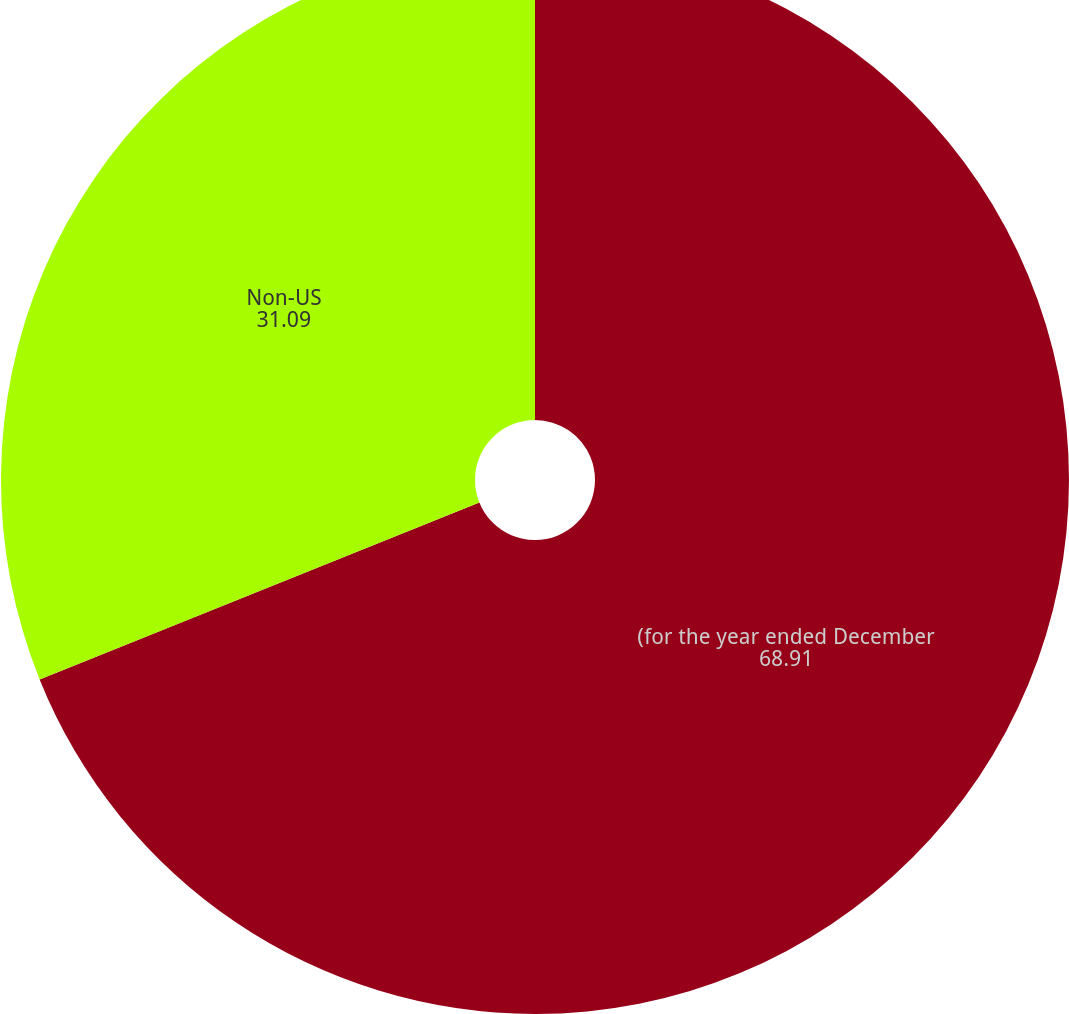<chart> <loc_0><loc_0><loc_500><loc_500><pie_chart><fcel>(for the year ended December<fcel>Non-US<nl><fcel>68.91%<fcel>31.09%<nl></chart> 